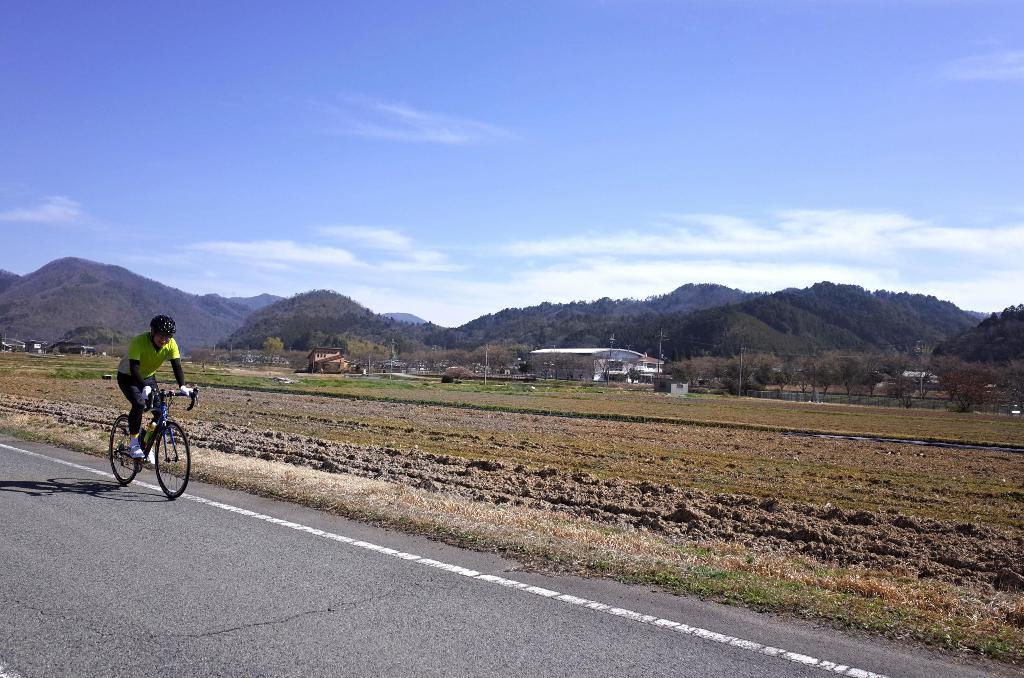What is the person in the image doing? The person is riding a vehicle in the image. What safety precaution is the person taking while riding the vehicle? The person is wearing a helmet. Where is the vehicle located? The vehicle is on the road. What can be seen in the background of the image? There is grass, trees, houses, poles, mountains, and the sky visible in the background of the image. What type of disease is the person suffering from in the image? There is no indication in the image that the person is suffering from any disease. Is the image taken during winter? The image does not provide any information about the season, so it cannot be determined if it was taken during winter. 